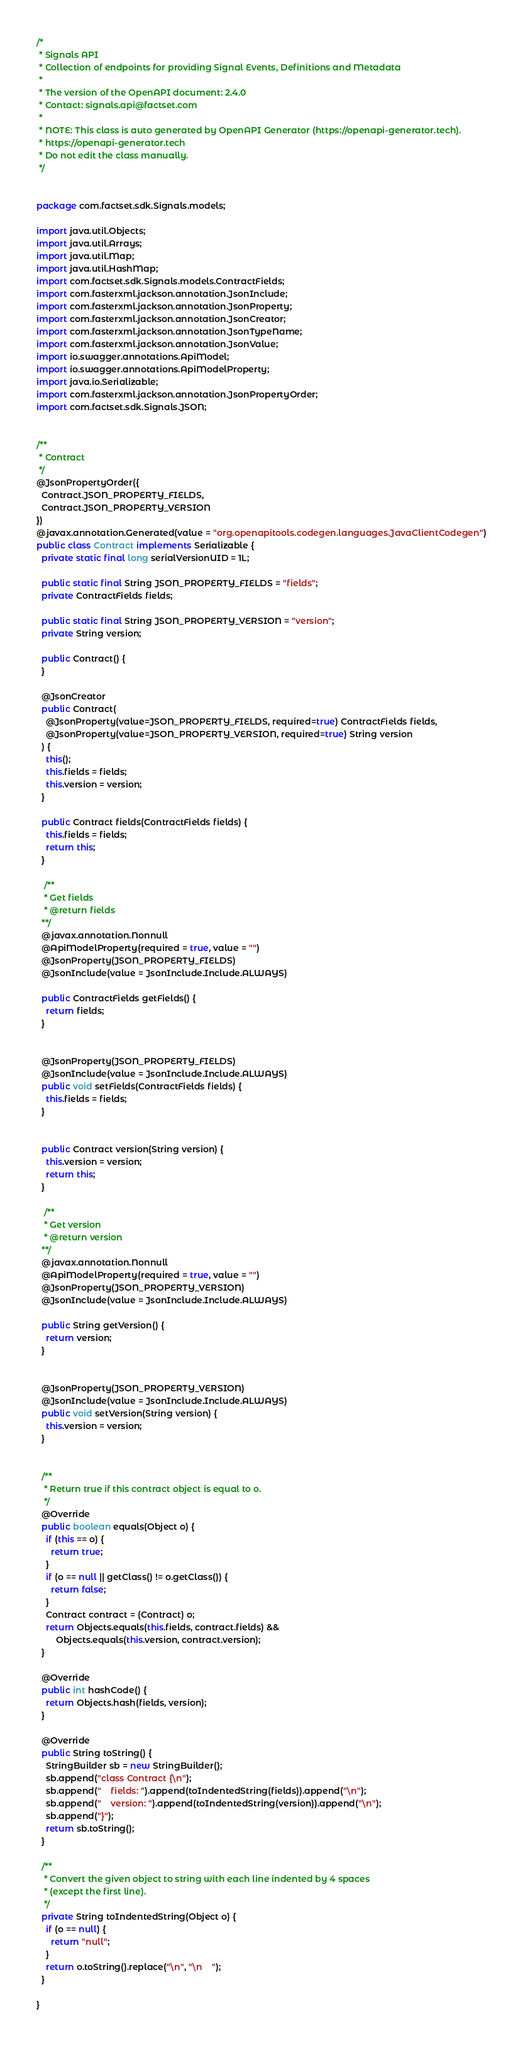<code> <loc_0><loc_0><loc_500><loc_500><_Java_>/*
 * Signals API
 * Collection of endpoints for providing Signal Events, Definitions and Metadata
 *
 * The version of the OpenAPI document: 2.4.0
 * Contact: signals.api@factset.com
 *
 * NOTE: This class is auto generated by OpenAPI Generator (https://openapi-generator.tech).
 * https://openapi-generator.tech
 * Do not edit the class manually.
 */


package com.factset.sdk.Signals.models;

import java.util.Objects;
import java.util.Arrays;
import java.util.Map;
import java.util.HashMap;
import com.factset.sdk.Signals.models.ContractFields;
import com.fasterxml.jackson.annotation.JsonInclude;
import com.fasterxml.jackson.annotation.JsonProperty;
import com.fasterxml.jackson.annotation.JsonCreator;
import com.fasterxml.jackson.annotation.JsonTypeName;
import com.fasterxml.jackson.annotation.JsonValue;
import io.swagger.annotations.ApiModel;
import io.swagger.annotations.ApiModelProperty;
import java.io.Serializable;
import com.fasterxml.jackson.annotation.JsonPropertyOrder;
import com.factset.sdk.Signals.JSON;


/**
 * Contract
 */
@JsonPropertyOrder({
  Contract.JSON_PROPERTY_FIELDS,
  Contract.JSON_PROPERTY_VERSION
})
@javax.annotation.Generated(value = "org.openapitools.codegen.languages.JavaClientCodegen")
public class Contract implements Serializable {
  private static final long serialVersionUID = 1L;

  public static final String JSON_PROPERTY_FIELDS = "fields";
  private ContractFields fields;

  public static final String JSON_PROPERTY_VERSION = "version";
  private String version;

  public Contract() { 
  }

  @JsonCreator
  public Contract(
    @JsonProperty(value=JSON_PROPERTY_FIELDS, required=true) ContractFields fields, 
    @JsonProperty(value=JSON_PROPERTY_VERSION, required=true) String version
  ) {
    this();
    this.fields = fields;
    this.version = version;
  }

  public Contract fields(ContractFields fields) {
    this.fields = fields;
    return this;
  }

   /**
   * Get fields
   * @return fields
  **/
  @javax.annotation.Nonnull
  @ApiModelProperty(required = true, value = "")
  @JsonProperty(JSON_PROPERTY_FIELDS)
  @JsonInclude(value = JsonInclude.Include.ALWAYS)

  public ContractFields getFields() {
    return fields;
  }


  @JsonProperty(JSON_PROPERTY_FIELDS)
  @JsonInclude(value = JsonInclude.Include.ALWAYS)
  public void setFields(ContractFields fields) {
    this.fields = fields;
  }


  public Contract version(String version) {
    this.version = version;
    return this;
  }

   /**
   * Get version
   * @return version
  **/
  @javax.annotation.Nonnull
  @ApiModelProperty(required = true, value = "")
  @JsonProperty(JSON_PROPERTY_VERSION)
  @JsonInclude(value = JsonInclude.Include.ALWAYS)

  public String getVersion() {
    return version;
  }


  @JsonProperty(JSON_PROPERTY_VERSION)
  @JsonInclude(value = JsonInclude.Include.ALWAYS)
  public void setVersion(String version) {
    this.version = version;
  }


  /**
   * Return true if this contract object is equal to o.
   */
  @Override
  public boolean equals(Object o) {
    if (this == o) {
      return true;
    }
    if (o == null || getClass() != o.getClass()) {
      return false;
    }
    Contract contract = (Contract) o;
    return Objects.equals(this.fields, contract.fields) &&
        Objects.equals(this.version, contract.version);
  }

  @Override
  public int hashCode() {
    return Objects.hash(fields, version);
  }

  @Override
  public String toString() {
    StringBuilder sb = new StringBuilder();
    sb.append("class Contract {\n");
    sb.append("    fields: ").append(toIndentedString(fields)).append("\n");
    sb.append("    version: ").append(toIndentedString(version)).append("\n");
    sb.append("}");
    return sb.toString();
  }

  /**
   * Convert the given object to string with each line indented by 4 spaces
   * (except the first line).
   */
  private String toIndentedString(Object o) {
    if (o == null) {
      return "null";
    }
    return o.toString().replace("\n", "\n    ");
  }

}

</code> 